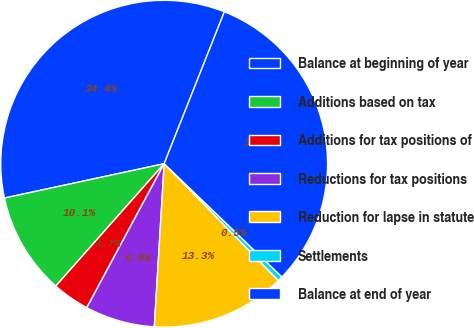Convert chart to OTSL. <chart><loc_0><loc_0><loc_500><loc_500><pie_chart><fcel>Balance at beginning of year<fcel>Additions based on tax<fcel>Additions for tax positions of<fcel>Reductions for tax positions<fcel>Reduction for lapse in statute<fcel>Settlements<fcel>Balance at end of year<nl><fcel>34.38%<fcel>10.09%<fcel>3.69%<fcel>6.89%<fcel>13.28%<fcel>0.49%<fcel>31.18%<nl></chart> 